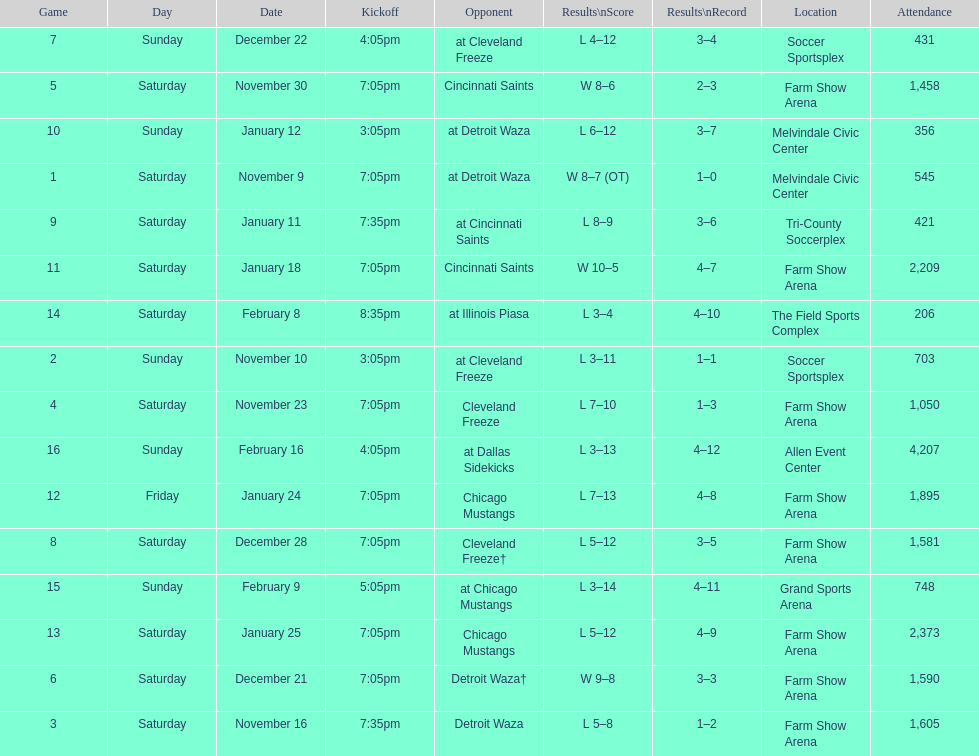Which opponent is listed first in the table? Detroit Waza. 